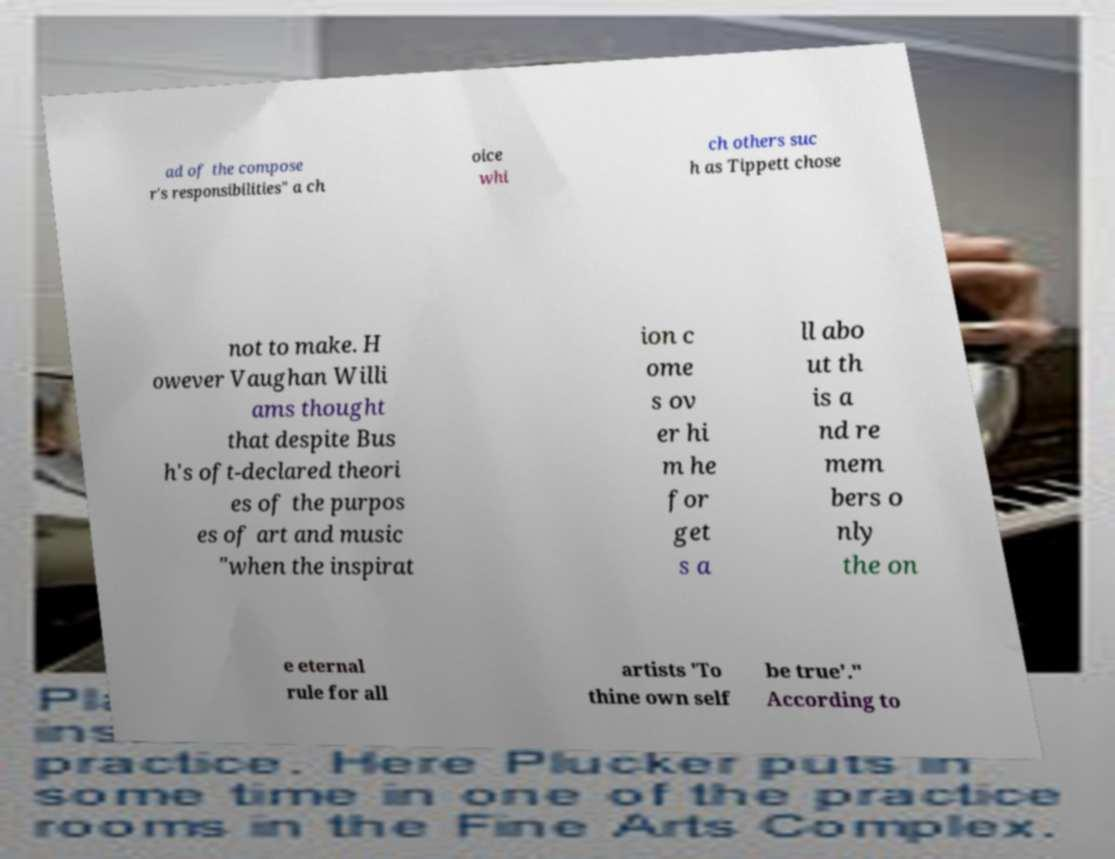Could you assist in decoding the text presented in this image and type it out clearly? ad of the compose r's responsibilities" a ch oice whi ch others suc h as Tippett chose not to make. H owever Vaughan Willi ams thought that despite Bus h's oft-declared theori es of the purpos es of art and music "when the inspirat ion c ome s ov er hi m he for get s a ll abo ut th is a nd re mem bers o nly the on e eternal rule for all artists 'To thine own self be true'." According to 